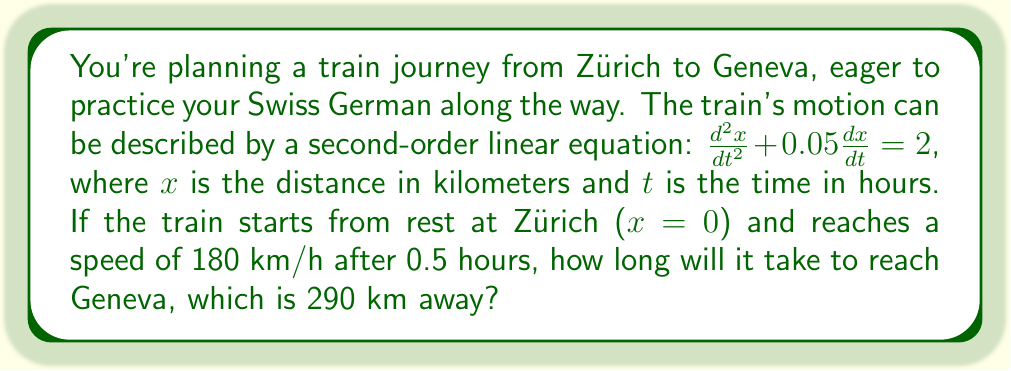Can you solve this math problem? Let's approach this step-by-step:

1) The given equation is $\frac{d^2x}{dt^2} + 0.05\frac{dx}{dt} = 2$

2) To solve this, we need two initial conditions:
   - $x(0) = 0$ (train starts at Zürich)
   - $v(0.5) = 180$ km/h (train reaches 180 km/h after 0.5 hours)

3) The general solution to this equation is:
   $$x(t) = At + B + 40t^2$$
   where A and B are constants we need to determine.

4) The velocity function is the derivative of x(t):
   $$v(t) = \frac{dx}{dt} = A + 80t$$

5) Using the first initial condition, $x(0) = 0$:
   $0 = B$
   So, $B = 0$

6) Using the second initial condition, $v(0.5) = 180$:
   $180 = A + 80(0.5)$
   $180 = A + 40$
   $A = 140$

7) Now we have our specific solution:
   $$x(t) = 140t + 40t^2$$

8) To find when the train reaches Geneva (290 km), we solve:
   $290 = 140t + 40t^2$
   $40t^2 + 140t - 290 = 0$

9) This is a quadratic equation. We can solve it using the quadratic formula:
   $$t = \frac{-b \pm \sqrt{b^2 - 4ac}}{2a}$$
   where $a = 40$, $b = 140$, and $c = -290$

10) Plugging in these values:
    $$t = \frac{-140 \pm \sqrt{140^2 - 4(40)(-290)}}{2(40)}$$
    $$= \frac{-140 \pm \sqrt{19600 + 46400}}{80}$$
    $$= \frac{-140 \pm \sqrt{66000}}{80}$$
    $$= \frac{-140 \pm 256.9}{80}$$

11) This gives us two solutions: $t \approx 1.46$ or $t \approx -4.96$

12) Since time cannot be negative in this context, we take the positive solution.

Therefore, it will take approximately 1.46 hours to reach Geneva.
Answer: 1.46 hours 